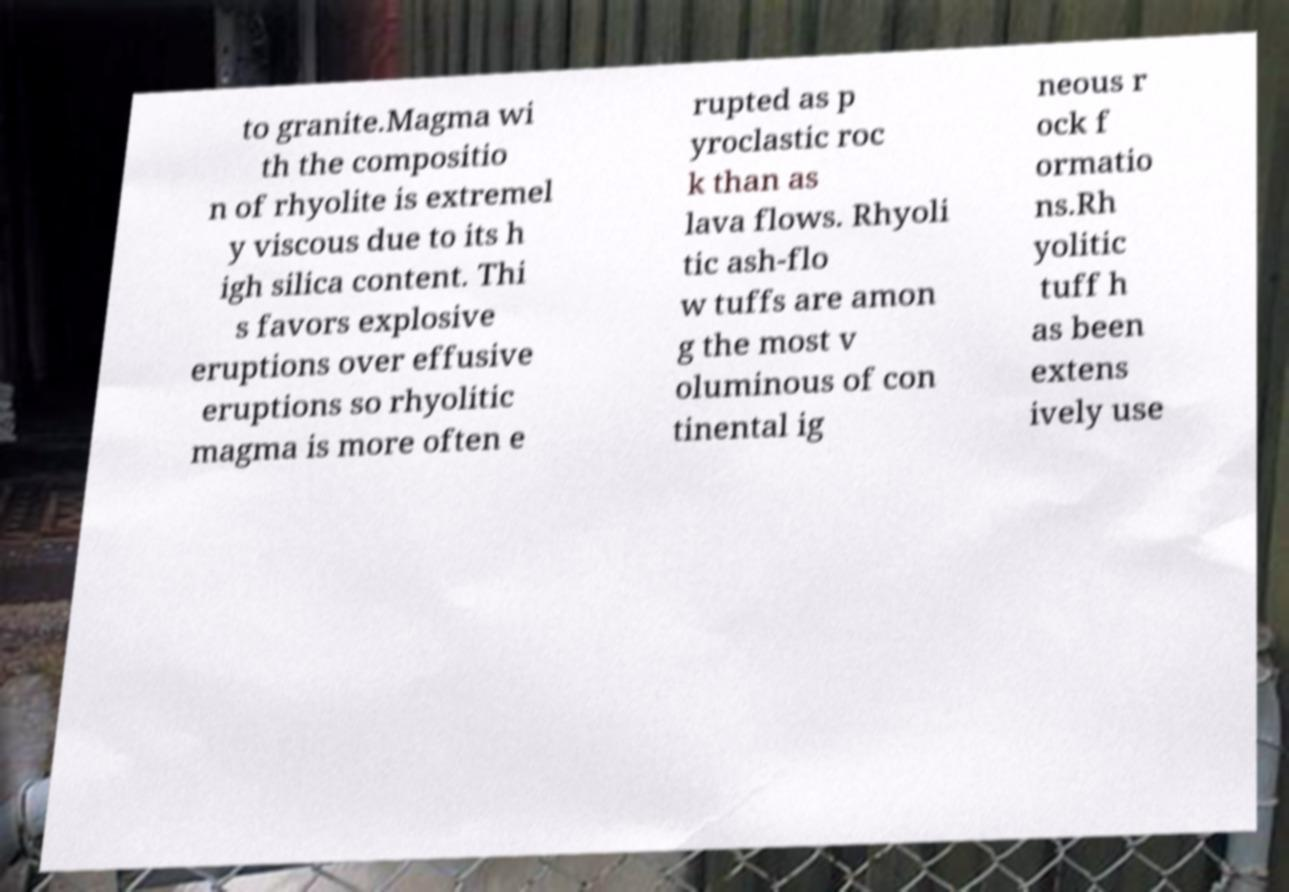Could you assist in decoding the text presented in this image and type it out clearly? to granite.Magma wi th the compositio n of rhyolite is extremel y viscous due to its h igh silica content. Thi s favors explosive eruptions over effusive eruptions so rhyolitic magma is more often e rupted as p yroclastic roc k than as lava flows. Rhyoli tic ash-flo w tuffs are amon g the most v oluminous of con tinental ig neous r ock f ormatio ns.Rh yolitic tuff h as been extens ively use 